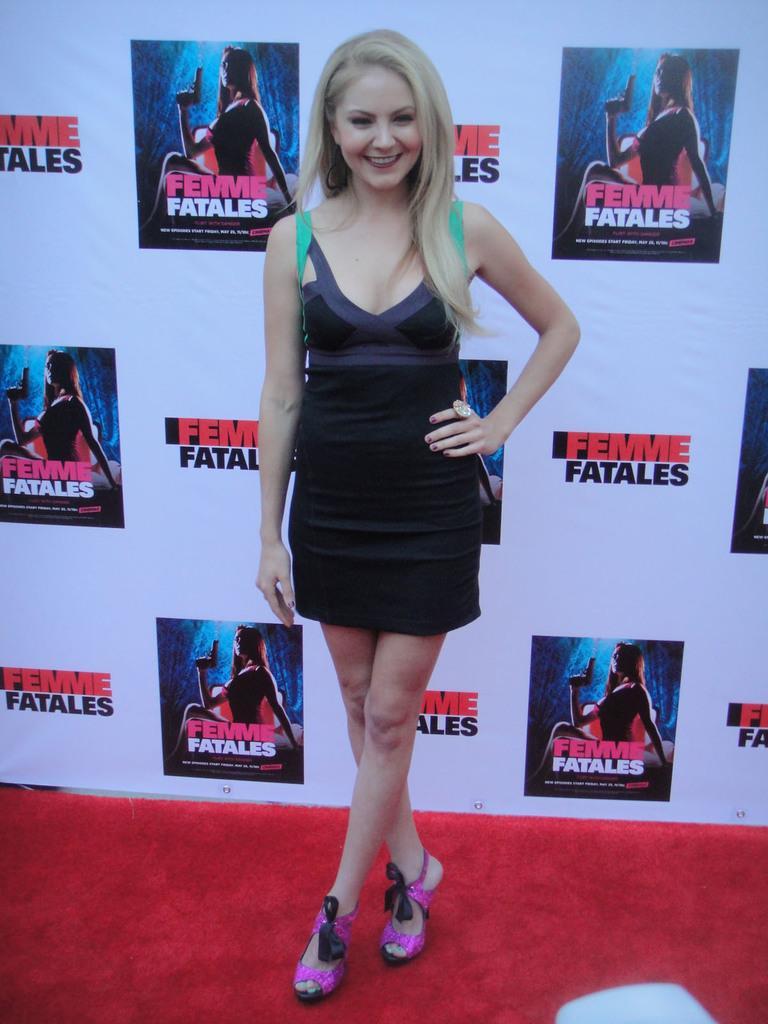Please provide a concise description of this image. In the center of the picture there is a woman standing on the carpet, behind her there is a banner. 